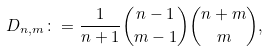Convert formula to latex. <formula><loc_0><loc_0><loc_500><loc_500>D _ { n , m } \colon = \frac { 1 } { n + 1 } \binom { n - 1 } { m - 1 } \binom { n + m } { m } ,</formula> 